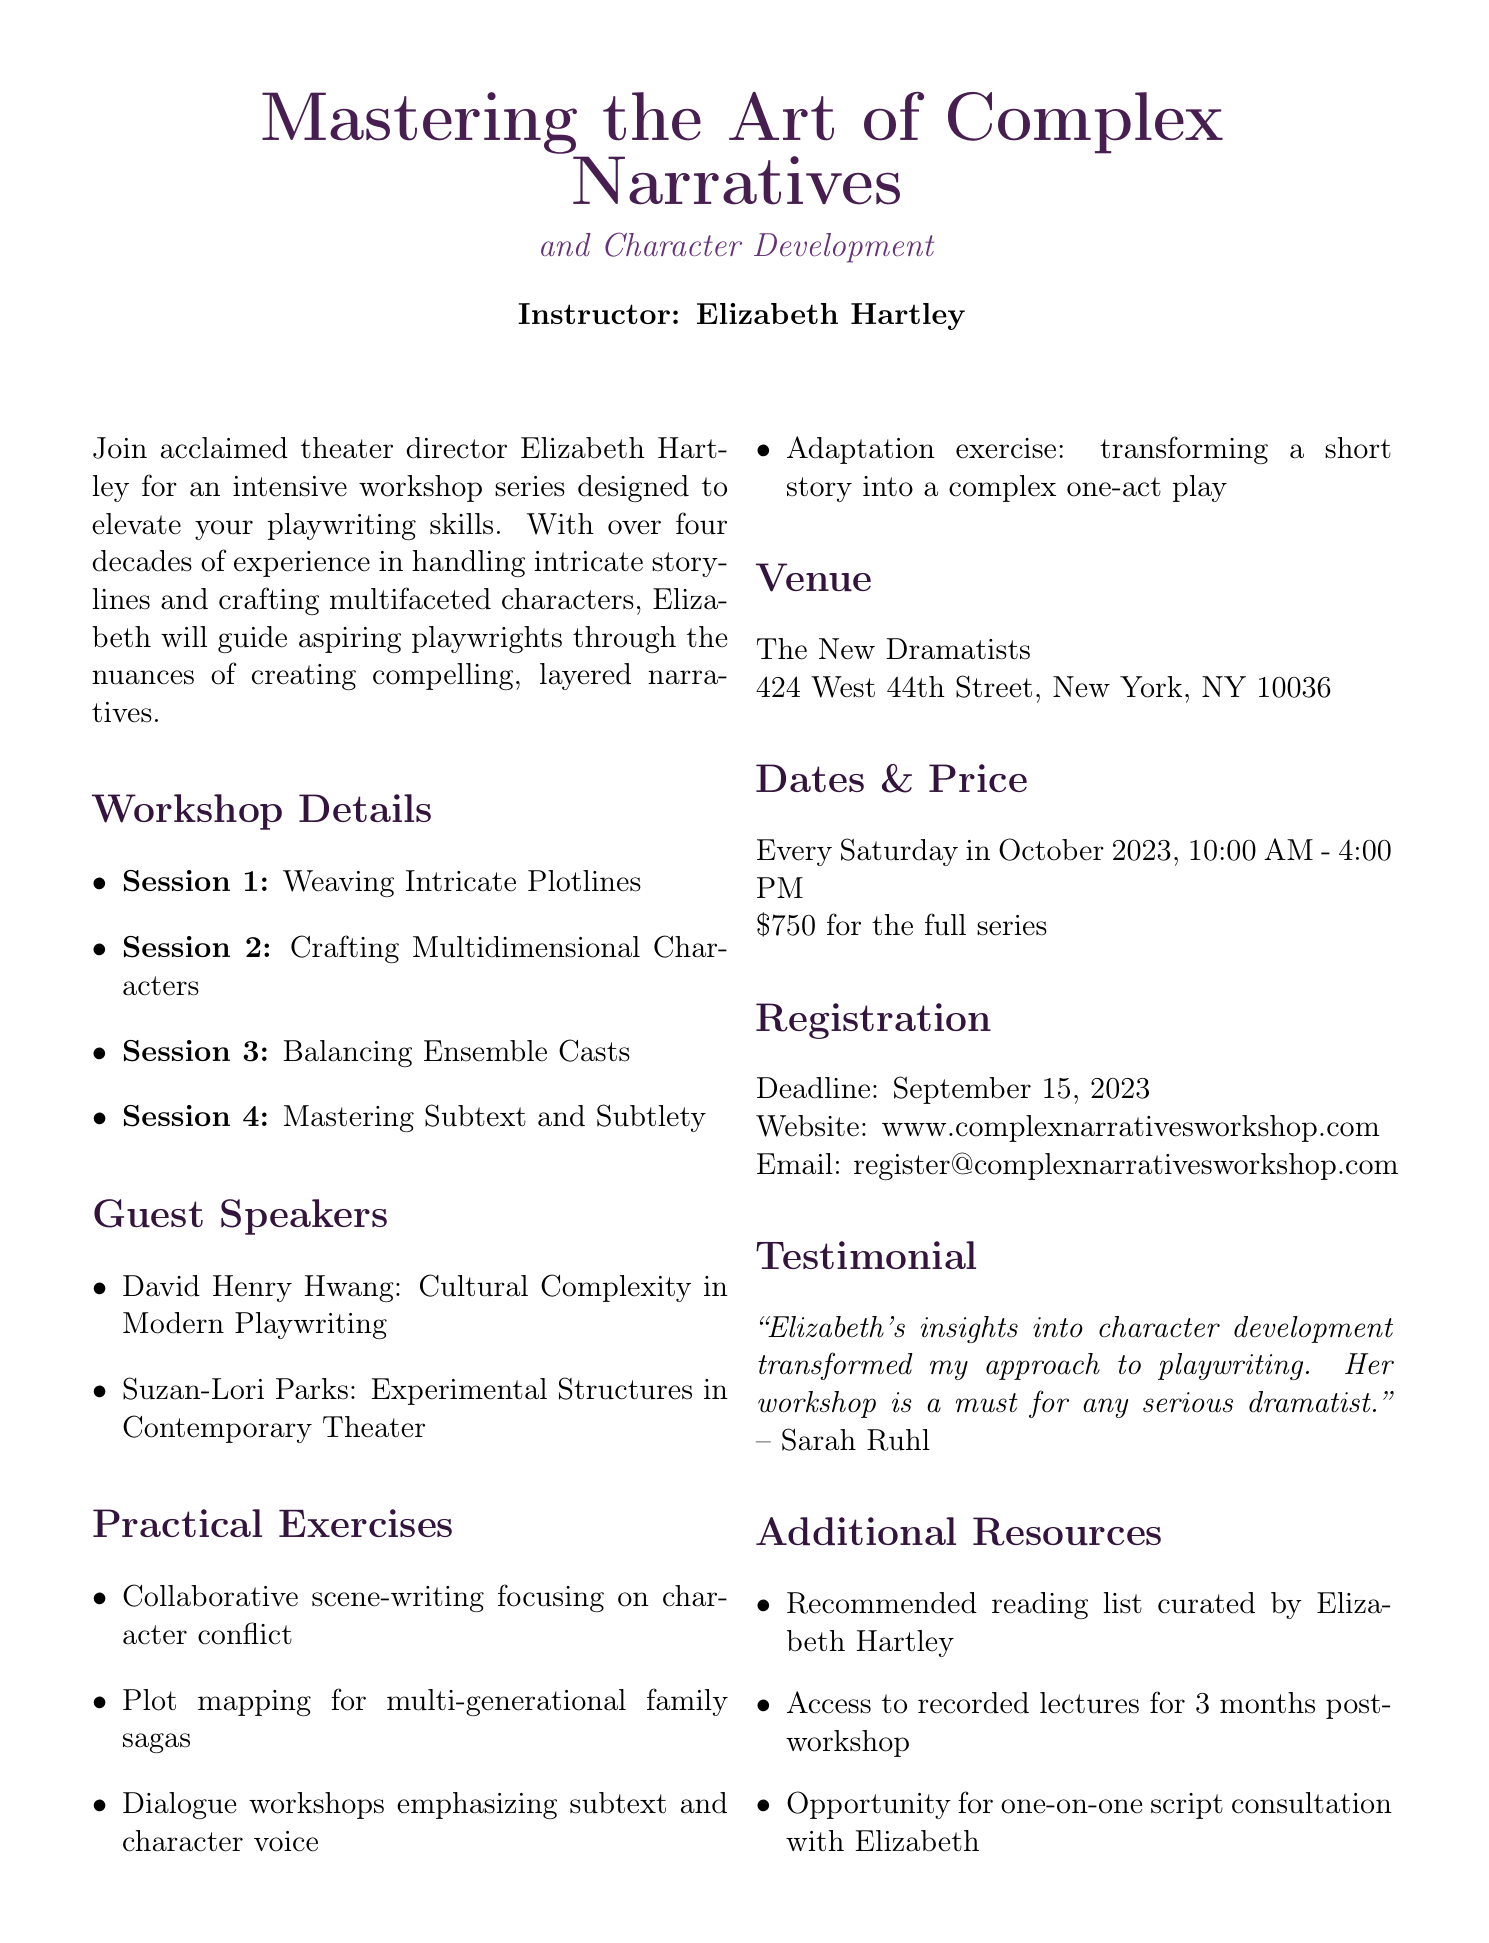What is the title of the workshop? The title of the workshop is stated at the beginning of the document.
Answer: Mastering the Art of Complex Narratives and Character Development Who is the instructor? The instructor's name is provided in the instructor section of the document.
Answer: Elizabeth Hartley What are the dates of the workshop? The document specifies the days of the workshop under the Dates section.
Answer: Every Saturday in October 2023 What is the price to attend the full series? The price is explicitly listed in the Dates & Price section of the document.
Answer: $750 What is the deadline for registration? The deadline is indicated clearly in the Registration section of the document.
Answer: September 15, 2023 Which session focuses on ensemble casts? The specific session on ensemble casts is detailed in the Workshop Details section.
Answer: Session 3: Balancing Ensemble Casts What type of exercises will participants engage in? The document lists various practical exercises under the Practical Exercises section.
Answer: Collaborative scene-writing Who is included as a guest speaker? The guest speakers are mentioned in the Guest Speakers section of the document.
Answer: David Henry Hwang What is a key focus of the second session? The key focus is detailed in the Workshop Details section regarding character development.
Answer: Crafting Multidimensional Characters 